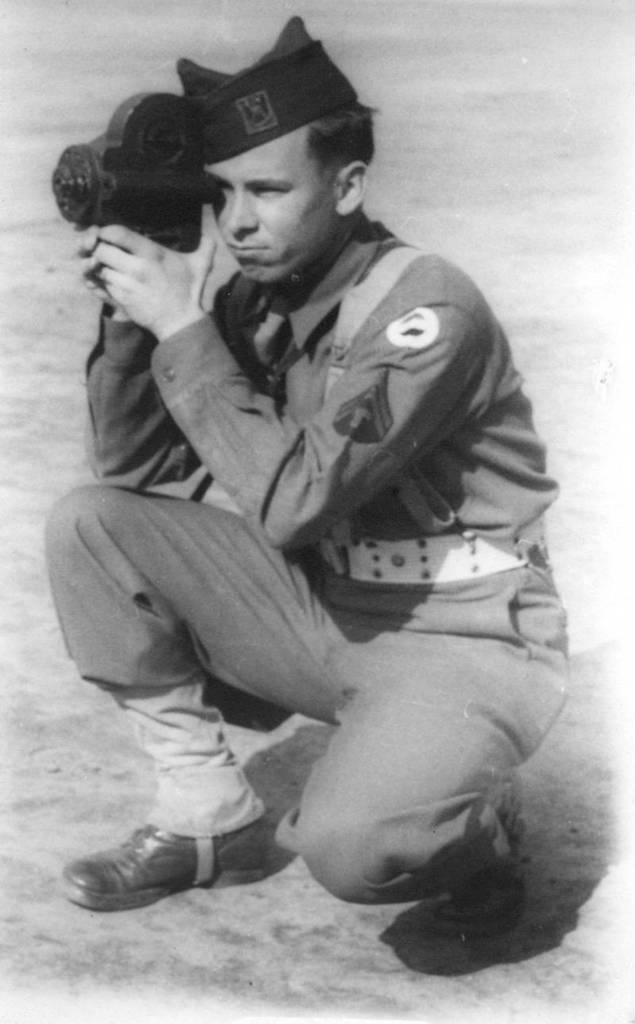Who is present in the image? There is a man in the image. What is the man wearing on his head? The man is wearing a cap. What type of clothing is the man wearing? The man is wearing a uniform. What is the man holding in the image? The man is holding an object. What can be seen in the background of the image? There is land visible in the background of the image. What type of dinner is the man preparing in the image? There is no indication of the man preparing dinner or any food in the image. 